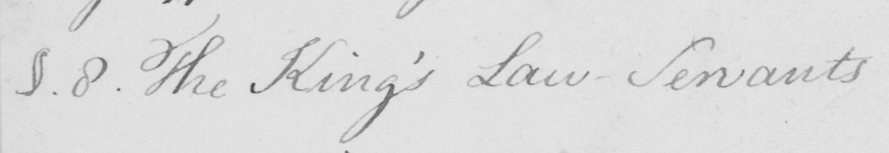What is written in this line of handwriting? §.8 . The King ' s Law-Servants 